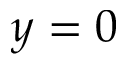Convert formula to latex. <formula><loc_0><loc_0><loc_500><loc_500>y = 0</formula> 